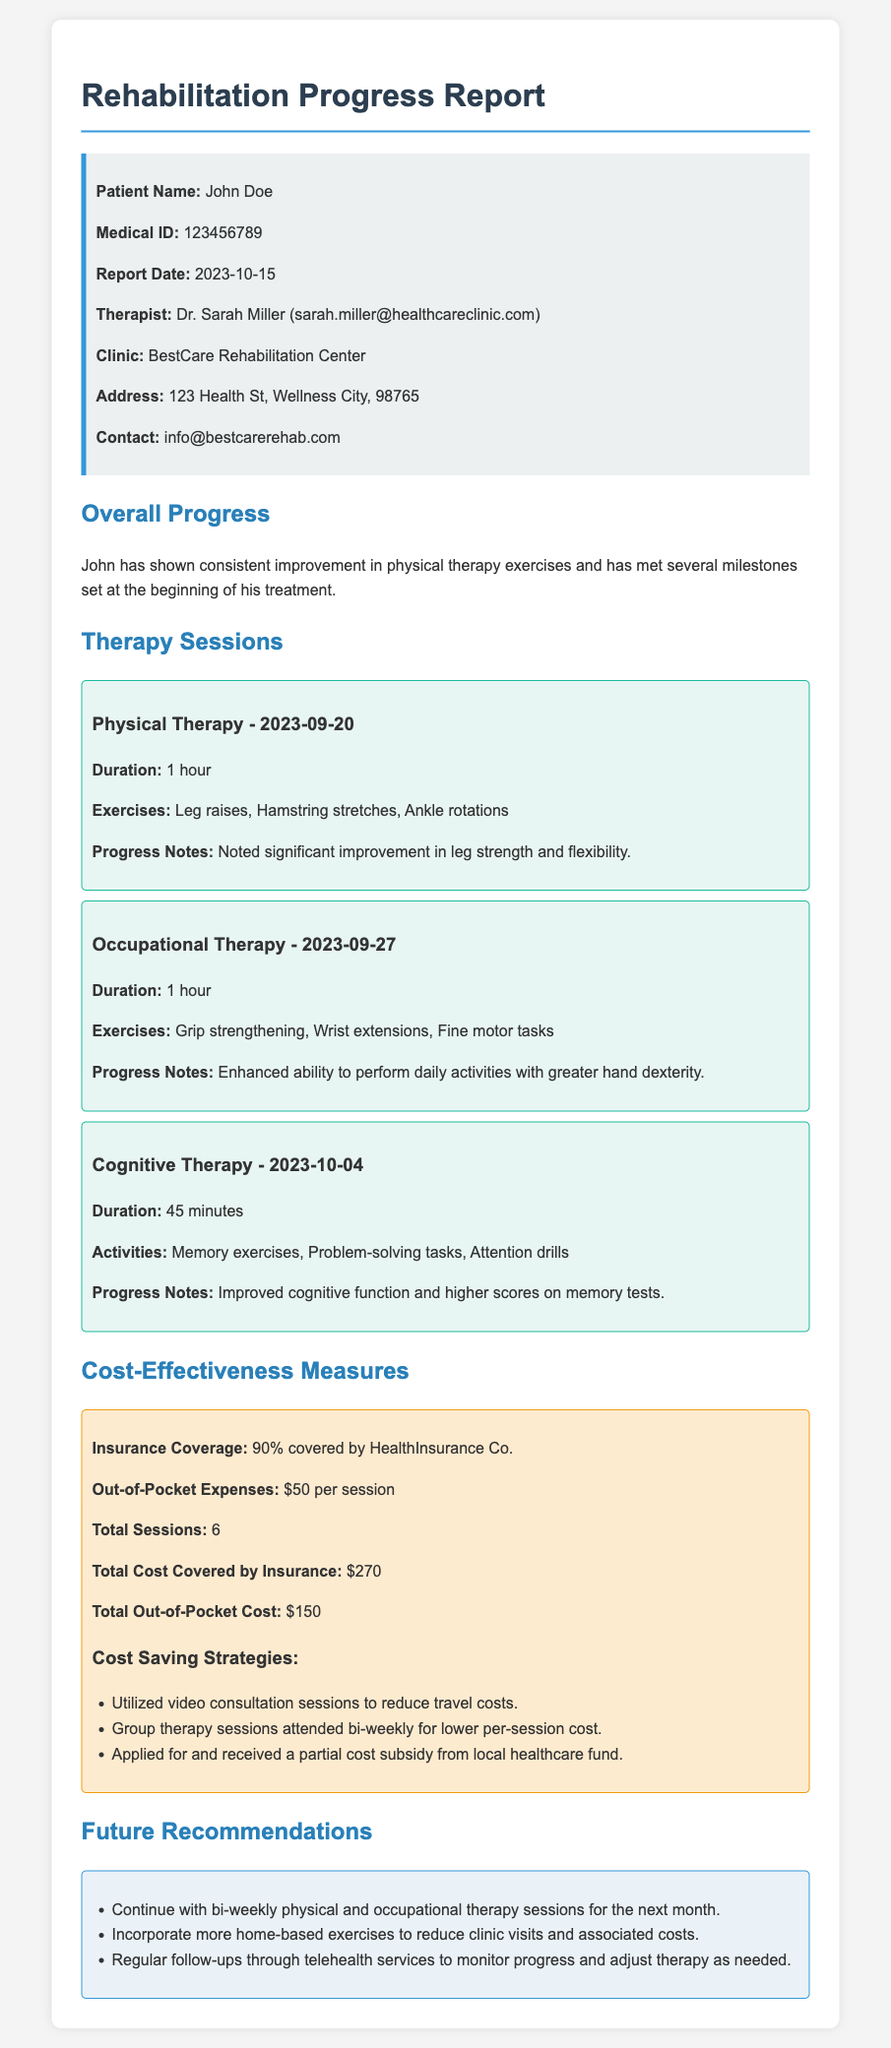What is the patient's name? The patient's name is mentioned in the patient info section of the document.
Answer: John Doe Who is the therapist? The therapist's name is listed in the patient info section.
Answer: Dr. Sarah Miller What is the date of the report? The report date is provided in the patient info section.
Answer: 2023-10-15 How many therapy sessions has John attended? The total sessions are summarized under the cost-effectiveness measures.
Answer: 6 What percentage of the cost is covered by insurance? The insurance coverage percentage is stated in the cost-effectiveness section of the report.
Answer: 90% What is the total out-of-pocket cost for the sessions? The total out-of-pocket cost is outlined in the cost-effectiveness measures.
Answer: $150 What type of therapy was conducted on 2023-09-20? The therapy type is specified in the therapy sessions section of the report.
Answer: Physical Therapy Which strategy is used to reduce travel costs? The specific cost-saving strategy is mentioned in the cost-effectiveness measures.
Answer: Utilized video consultation sessions What should John continue for the next month? This recommendation is included in the future recommendations section.
Answer: Bi-weekly physical and occupational therapy sessions 